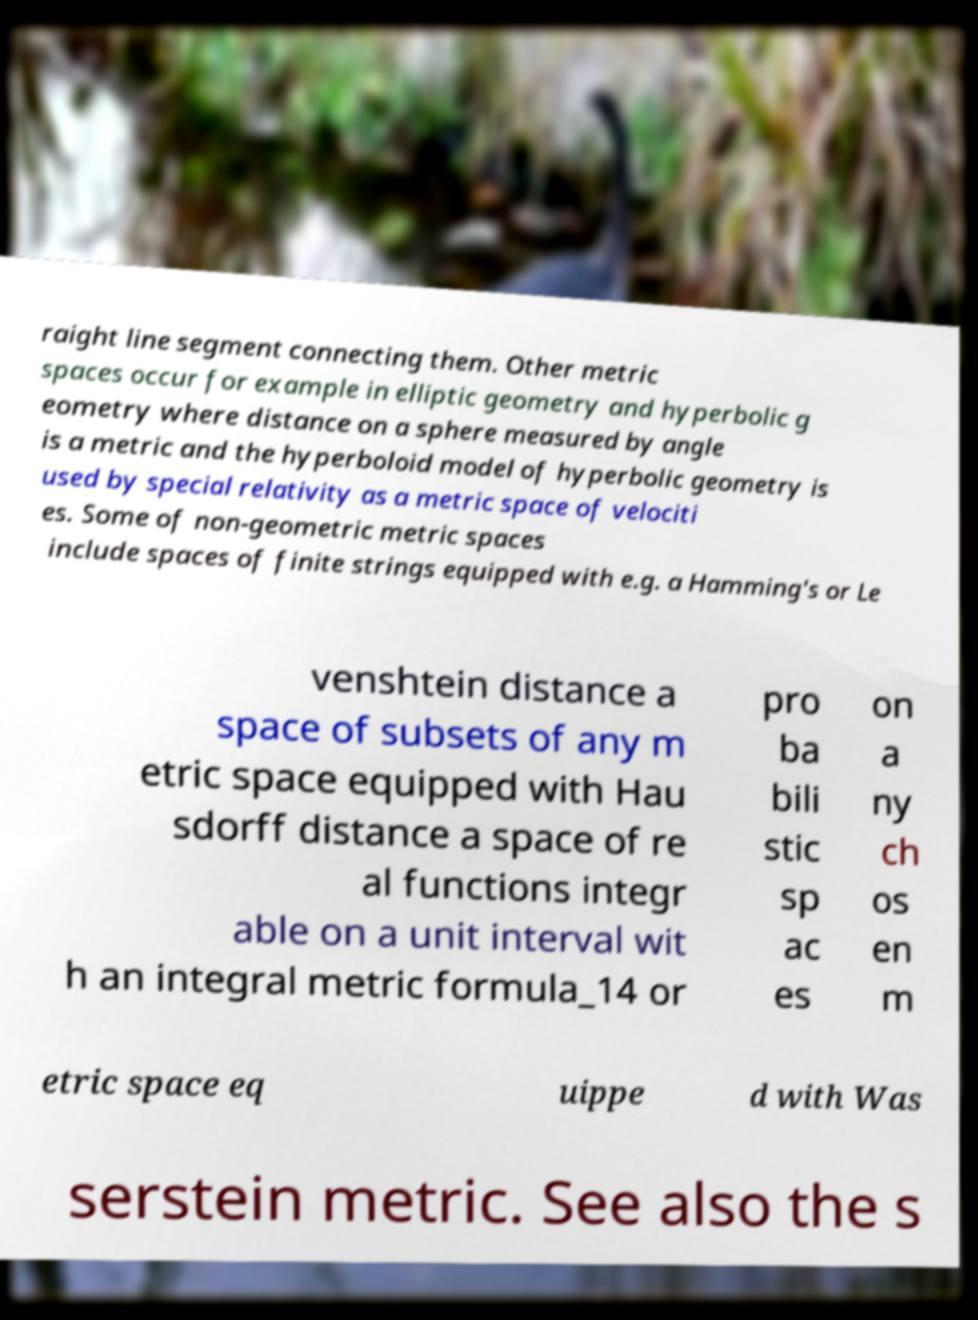Please read and relay the text visible in this image. What does it say? raight line segment connecting them. Other metric spaces occur for example in elliptic geometry and hyperbolic g eometry where distance on a sphere measured by angle is a metric and the hyperboloid model of hyperbolic geometry is used by special relativity as a metric space of velociti es. Some of non-geometric metric spaces include spaces of finite strings equipped with e.g. a Hamming's or Le venshtein distance a space of subsets of any m etric space equipped with Hau sdorff distance a space of re al functions integr able on a unit interval wit h an integral metric formula_14 or pro ba bili stic sp ac es on a ny ch os en m etric space eq uippe d with Was serstein metric. See also the s 